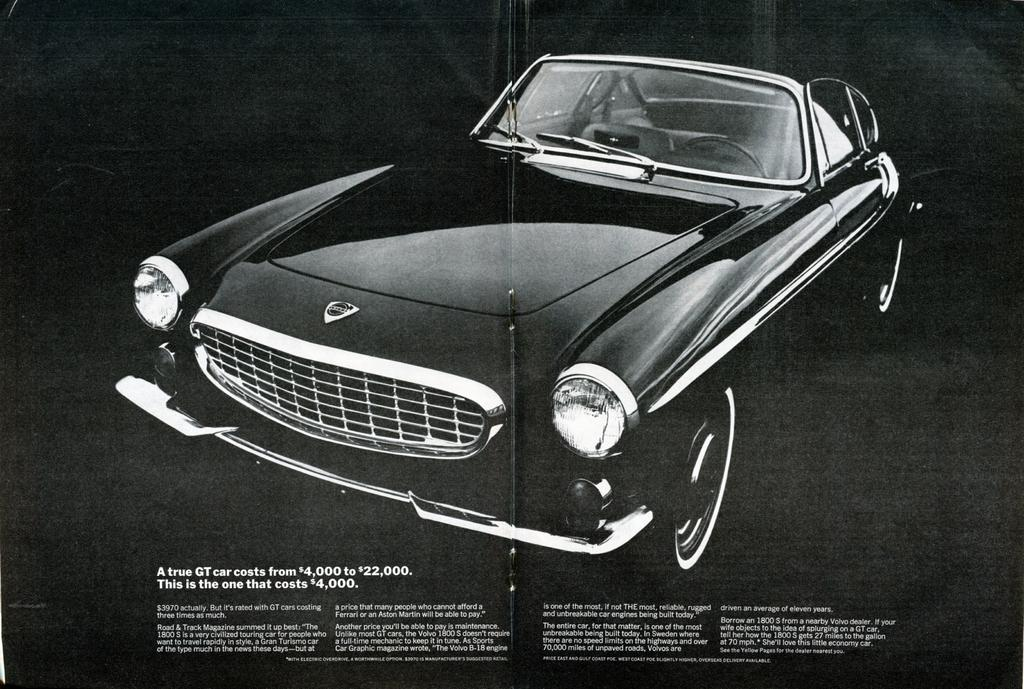What is the main object in the image? There is a poster in the image. What else can be seen in the image besides the poster? There is a car in the image. Is there any text present in the image? Yes, there is text in the image. What is the color of the background in the image? The background of the image is black in color. Can you see a goose cooking stew in the image? No, there is no goose or stew present in the image. 